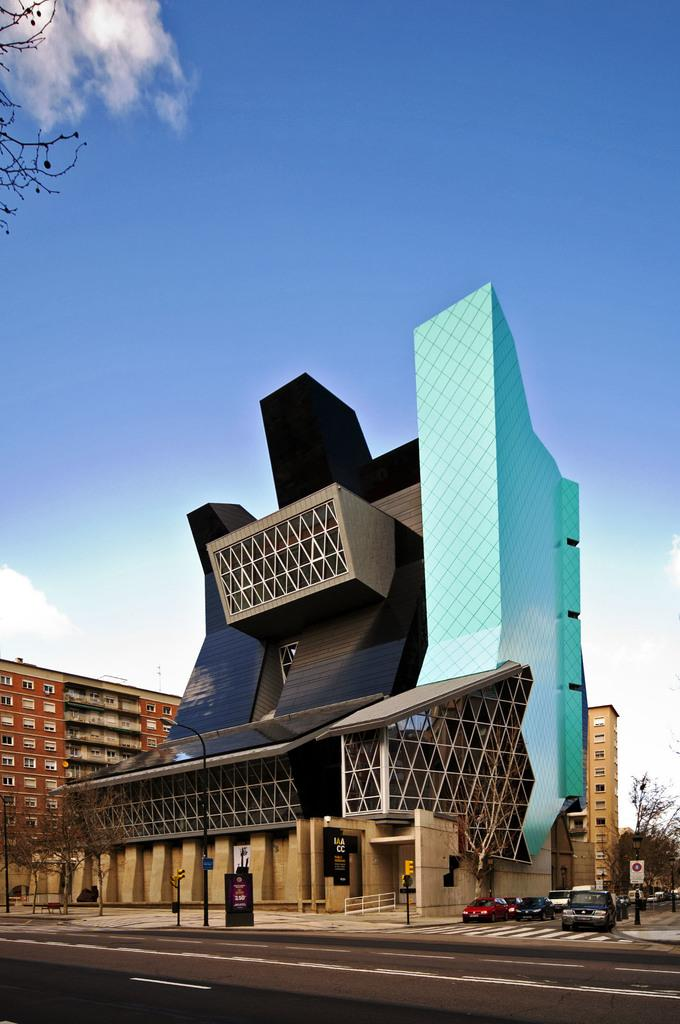What types of objects can be seen in the image? There are vehicles, light poles, buildings, and trees in the image. What is the color of the sky in the image? The sky is blue and white in color. Can you see any shaded areas under the trees in the image? There is no mention of shaded areas or the presence of shade in the image. --- Facts: 1. There is a person holding a camera in the image. 2. The person is wearing a hat. 3. The person is standing near a fence. 4. There is a field in the background of the image. 5. The field has flowers. Absurd Topics: parrot, sand, volcano Conversation: What is the person in the image doing? The person is holding a camera in the image. What is the person wearing on their head? The person is wearing a hat. Where is the person standing in relation to the fence? The person is standing near a fence. What can be seen in the background of the image? There is a field in the background of the image, and it has flowers. Reasoning: Let's think step by step in order to produce the conversation. We start by identifying the main subject in the image, which is the person holding a camera. Then, we expand the conversation to include other details about the person, such as their hat and their proximity to the fence. Finally, we describe the background of the image, which includes a field with flowers. We avoid asking questions that cannot be answered definitively with the provided facts. Absurd Question/Answer: Can you see any parrots flying over the field in the image? There is no mention of parrots or any birds in the image. 